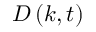Convert formula to latex. <formula><loc_0><loc_0><loc_500><loc_500>{ D } \left ( { k , t } \right )</formula> 